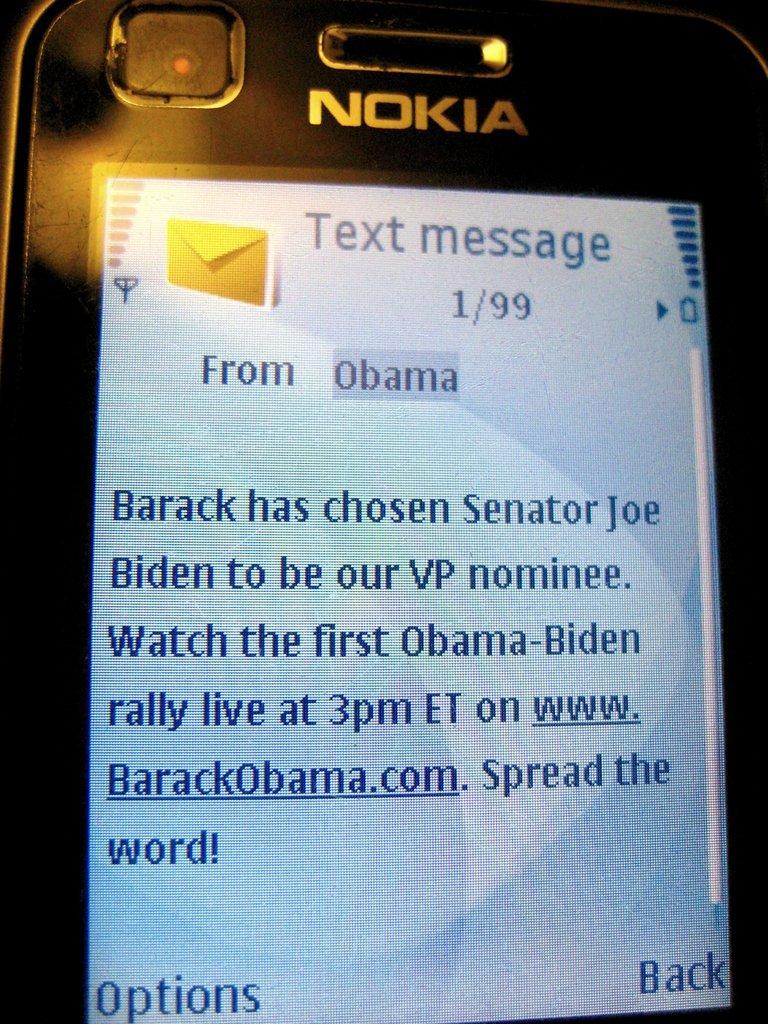Who is the text from?
Ensure brevity in your answer.  Obama. 